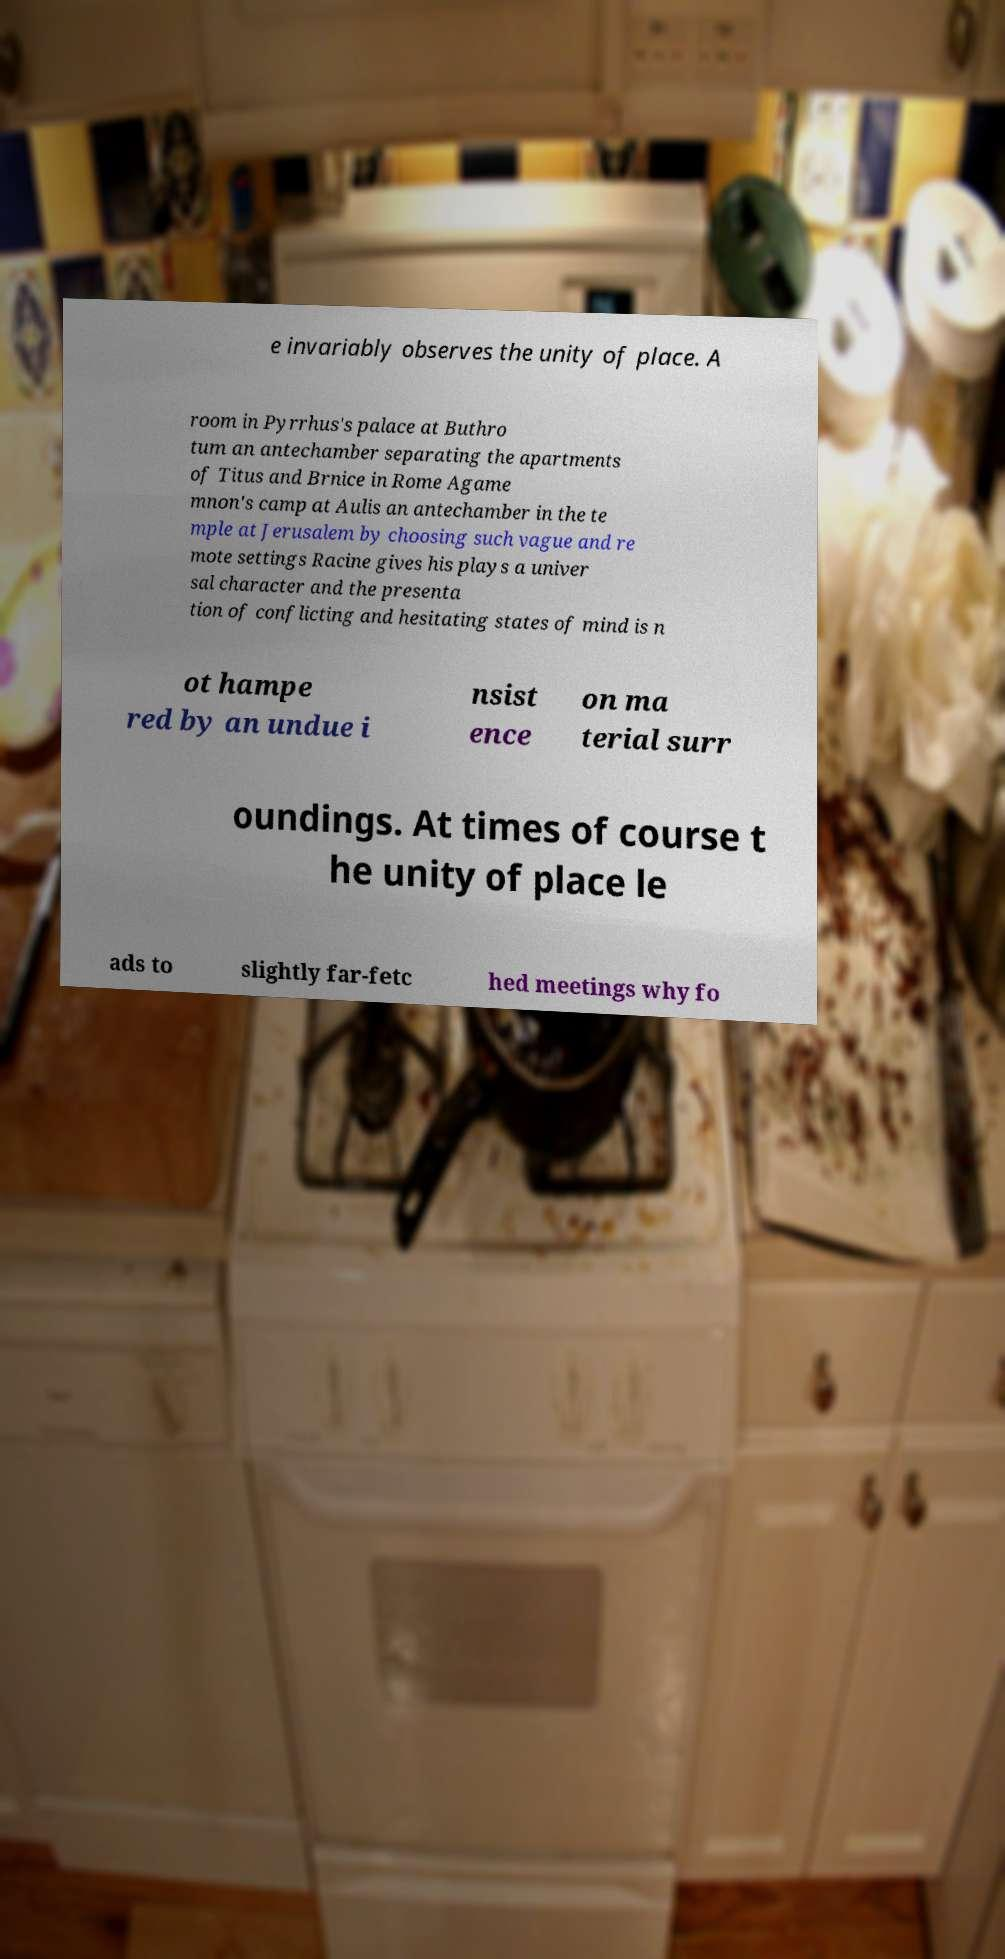There's text embedded in this image that I need extracted. Can you transcribe it verbatim? e invariably observes the unity of place. A room in Pyrrhus's palace at Buthro tum an antechamber separating the apartments of Titus and Brnice in Rome Agame mnon's camp at Aulis an antechamber in the te mple at Jerusalem by choosing such vague and re mote settings Racine gives his plays a univer sal character and the presenta tion of conflicting and hesitating states of mind is n ot hampe red by an undue i nsist ence on ma terial surr oundings. At times of course t he unity of place le ads to slightly far-fetc hed meetings why fo 